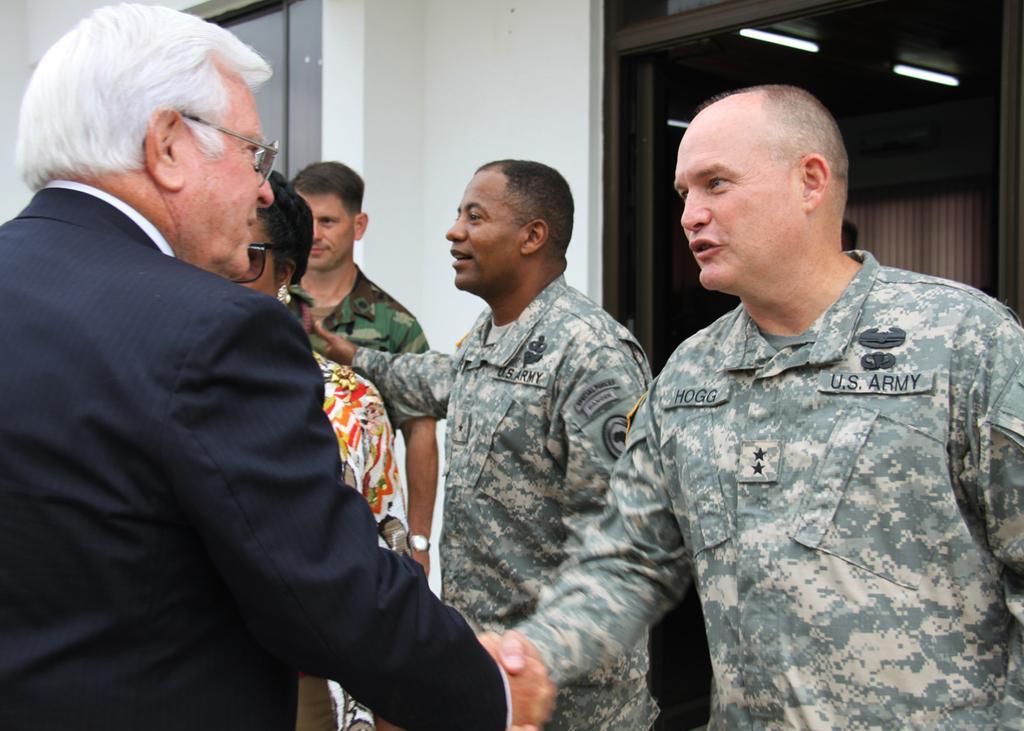Describe this image in one or two sentences. In this picture we can see five people standing where two men are shaking hands and in the background we can see a window, wall, lights and curtains. 